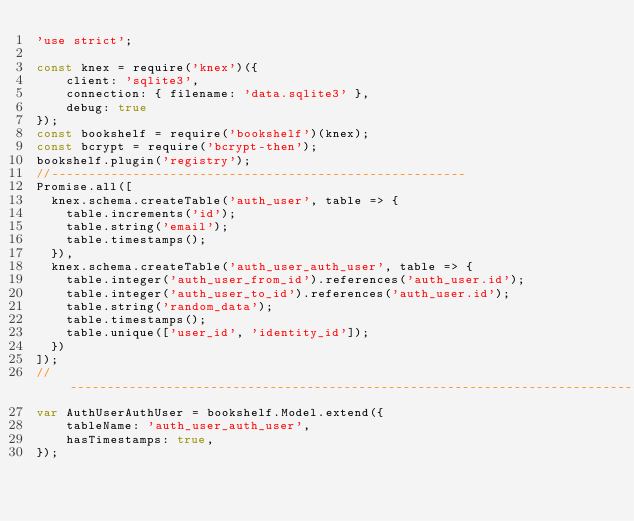Convert code to text. <code><loc_0><loc_0><loc_500><loc_500><_JavaScript_>'use strict';

const knex = require('knex')({
    client: 'sqlite3',
    connection: { filename: 'data.sqlite3' },
    debug: true
});
const bookshelf = require('bookshelf')(knex);
const bcrypt = require('bcrypt-then');
bookshelf.plugin('registry');
//--------------------------------------------------------
Promise.all([
  knex.schema.createTable('auth_user', table => {
    table.increments('id');
    table.string('email');
    table.timestamps();
  }),
  knex.schema.createTable('auth_user_auth_user', table => {
    table.integer('auth_user_from_id').references('auth_user.id');
    table.integer('auth_user_to_id').references('auth_user.id');
    table.string('random_data');
    table.timestamps();
    table.unique(['user_id', 'identity_id']);
  })
]);
//--------------------------------------------------------------------------------
var AuthUserAuthUser = bookshelf.Model.extend({
    tableName: 'auth_user_auth_user',
    hasTimestamps: true,
});
</code> 